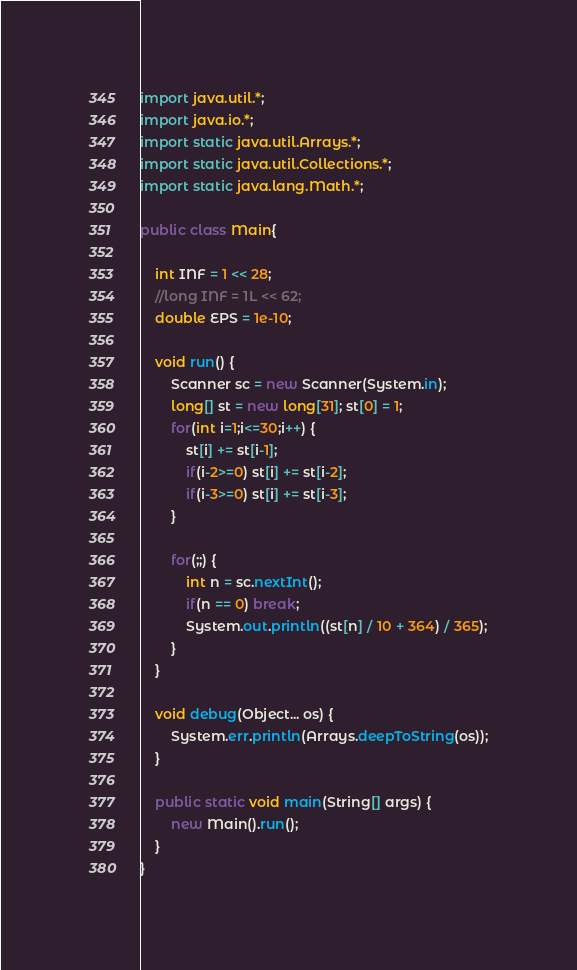<code> <loc_0><loc_0><loc_500><loc_500><_Java_>
import java.util.*;
import java.io.*;
import static java.util.Arrays.*;
import static java.util.Collections.*;
import static java.lang.Math.*;

public class Main{

	int INF = 1 << 28;
	//long INF = 1L << 62;
	double EPS = 1e-10;

	void run() {
		Scanner sc = new Scanner(System.in);
		long[] st = new long[31]; st[0] = 1;
		for(int i=1;i<=30;i++) {
			st[i] += st[i-1];
			if(i-2>=0) st[i] += st[i-2];
			if(i-3>=0) st[i] += st[i-3];
		}
		
		for(;;) {
			int n = sc.nextInt();
			if(n == 0) break;
			System.out.println((st[n] / 10 + 364) / 365);
		}
	}

	void debug(Object... os) {
		System.err.println(Arrays.deepToString(os));
	}

	public static void main(String[] args) {
		new Main().run();
	}
}</code> 